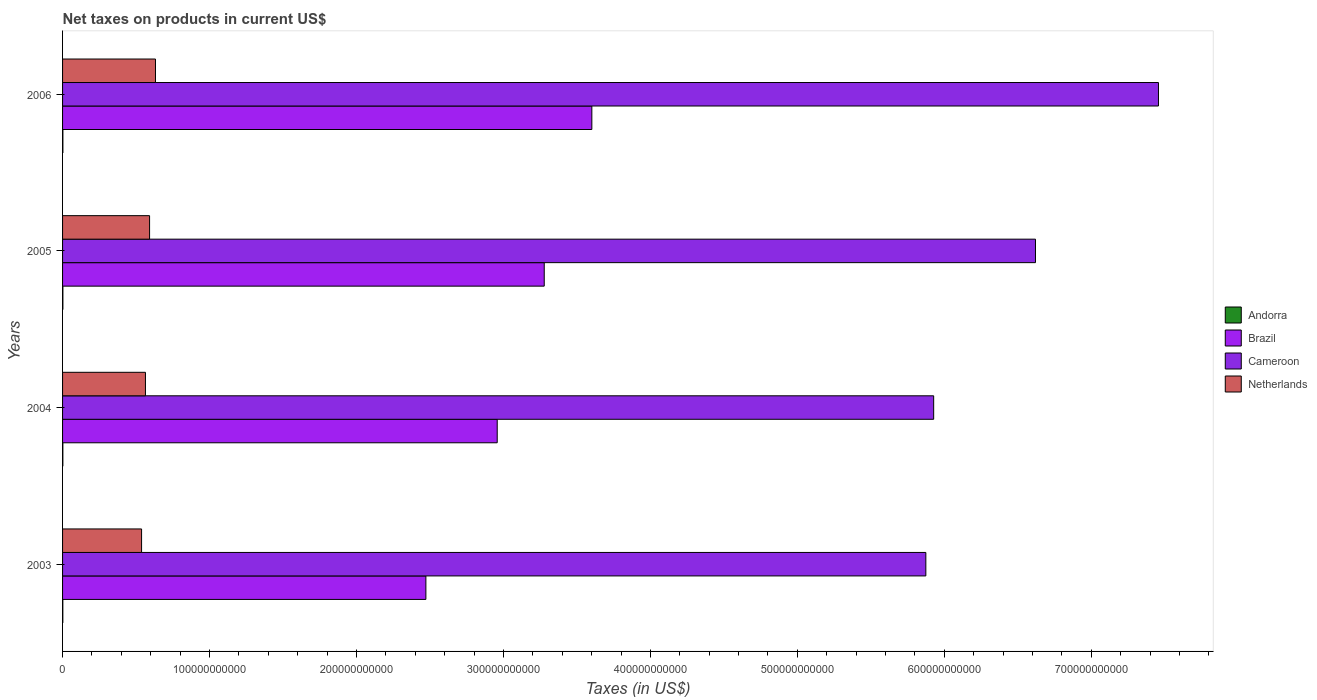Are the number of bars per tick equal to the number of legend labels?
Offer a terse response. Yes. How many bars are there on the 4th tick from the top?
Provide a succinct answer. 4. How many bars are there on the 1st tick from the bottom?
Ensure brevity in your answer.  4. What is the label of the 4th group of bars from the top?
Your response must be concise. 2003. What is the net taxes on products in Cameroon in 2005?
Your response must be concise. 6.62e+11. Across all years, what is the maximum net taxes on products in Brazil?
Make the answer very short. 3.60e+11. Across all years, what is the minimum net taxes on products in Andorra?
Your answer should be very brief. 1.74e+08. In which year was the net taxes on products in Cameroon maximum?
Offer a terse response. 2006. What is the total net taxes on products in Netherlands in the graph?
Your answer should be compact. 2.33e+11. What is the difference between the net taxes on products in Netherlands in 2004 and that in 2006?
Provide a short and direct response. -6.83e+09. What is the difference between the net taxes on products in Cameroon in 2006 and the net taxes on products in Brazil in 2003?
Offer a very short reply. 4.98e+11. What is the average net taxes on products in Netherlands per year?
Your response must be concise. 5.82e+1. In the year 2003, what is the difference between the net taxes on products in Brazil and net taxes on products in Netherlands?
Your answer should be very brief. 1.93e+11. What is the ratio of the net taxes on products in Brazil in 2004 to that in 2006?
Give a very brief answer. 0.82. Is the net taxes on products in Brazil in 2004 less than that in 2006?
Keep it short and to the point. Yes. What is the difference between the highest and the second highest net taxes on products in Brazil?
Offer a very short reply. 3.24e+1. What is the difference between the highest and the lowest net taxes on products in Cameroon?
Provide a short and direct response. 1.58e+11. Is it the case that in every year, the sum of the net taxes on products in Andorra and net taxes on products in Netherlands is greater than the sum of net taxes on products in Cameroon and net taxes on products in Brazil?
Ensure brevity in your answer.  No. What does the 1st bar from the top in 2003 represents?
Give a very brief answer. Netherlands. What does the 3rd bar from the bottom in 2005 represents?
Offer a terse response. Cameroon. How many bars are there?
Offer a terse response. 16. How many years are there in the graph?
Offer a terse response. 4. What is the difference between two consecutive major ticks on the X-axis?
Your response must be concise. 1.00e+11. Are the values on the major ticks of X-axis written in scientific E-notation?
Your answer should be very brief. No. Where does the legend appear in the graph?
Offer a terse response. Center right. How many legend labels are there?
Provide a succinct answer. 4. What is the title of the graph?
Offer a very short reply. Net taxes on products in current US$. Does "Malawi" appear as one of the legend labels in the graph?
Offer a very short reply. No. What is the label or title of the X-axis?
Give a very brief answer. Taxes (in US$). What is the Taxes (in US$) of Andorra in 2003?
Provide a succinct answer. 1.74e+08. What is the Taxes (in US$) of Brazil in 2003?
Provide a succinct answer. 2.47e+11. What is the Taxes (in US$) of Cameroon in 2003?
Ensure brevity in your answer.  5.87e+11. What is the Taxes (in US$) of Netherlands in 2003?
Provide a short and direct response. 5.38e+1. What is the Taxes (in US$) in Andorra in 2004?
Your answer should be very brief. 2.00e+08. What is the Taxes (in US$) of Brazil in 2004?
Give a very brief answer. 2.96e+11. What is the Taxes (in US$) of Cameroon in 2004?
Make the answer very short. 5.93e+11. What is the Taxes (in US$) in Netherlands in 2004?
Your response must be concise. 5.64e+1. What is the Taxes (in US$) of Andorra in 2005?
Make the answer very short. 2.24e+08. What is the Taxes (in US$) of Brazil in 2005?
Your answer should be compact. 3.28e+11. What is the Taxes (in US$) of Cameroon in 2005?
Offer a terse response. 6.62e+11. What is the Taxes (in US$) in Netherlands in 2005?
Your answer should be compact. 5.92e+1. What is the Taxes (in US$) in Andorra in 2006?
Offer a terse response. 2.23e+08. What is the Taxes (in US$) of Brazil in 2006?
Keep it short and to the point. 3.60e+11. What is the Taxes (in US$) of Cameroon in 2006?
Keep it short and to the point. 7.46e+11. What is the Taxes (in US$) in Netherlands in 2006?
Make the answer very short. 6.32e+1. Across all years, what is the maximum Taxes (in US$) of Andorra?
Give a very brief answer. 2.24e+08. Across all years, what is the maximum Taxes (in US$) of Brazil?
Offer a terse response. 3.60e+11. Across all years, what is the maximum Taxes (in US$) of Cameroon?
Your answer should be very brief. 7.46e+11. Across all years, what is the maximum Taxes (in US$) of Netherlands?
Ensure brevity in your answer.  6.32e+1. Across all years, what is the minimum Taxes (in US$) in Andorra?
Ensure brevity in your answer.  1.74e+08. Across all years, what is the minimum Taxes (in US$) in Brazil?
Offer a very short reply. 2.47e+11. Across all years, what is the minimum Taxes (in US$) of Cameroon?
Your answer should be compact. 5.87e+11. Across all years, what is the minimum Taxes (in US$) in Netherlands?
Your response must be concise. 5.38e+1. What is the total Taxes (in US$) of Andorra in the graph?
Your response must be concise. 8.20e+08. What is the total Taxes (in US$) in Brazil in the graph?
Provide a succinct answer. 1.23e+12. What is the total Taxes (in US$) of Cameroon in the graph?
Ensure brevity in your answer.  2.59e+12. What is the total Taxes (in US$) of Netherlands in the graph?
Provide a succinct answer. 2.33e+11. What is the difference between the Taxes (in US$) of Andorra in 2003 and that in 2004?
Your response must be concise. -2.60e+07. What is the difference between the Taxes (in US$) in Brazil in 2003 and that in 2004?
Offer a very short reply. -4.85e+1. What is the difference between the Taxes (in US$) in Cameroon in 2003 and that in 2004?
Your answer should be very brief. -5.34e+09. What is the difference between the Taxes (in US$) of Netherlands in 2003 and that in 2004?
Offer a terse response. -2.63e+09. What is the difference between the Taxes (in US$) of Andorra in 2003 and that in 2005?
Your response must be concise. -5.02e+07. What is the difference between the Taxes (in US$) of Brazil in 2003 and that in 2005?
Provide a short and direct response. -8.05e+1. What is the difference between the Taxes (in US$) in Cameroon in 2003 and that in 2005?
Offer a very short reply. -7.46e+1. What is the difference between the Taxes (in US$) of Netherlands in 2003 and that in 2005?
Provide a short and direct response. -5.44e+09. What is the difference between the Taxes (in US$) in Andorra in 2003 and that in 2006?
Give a very brief answer. -4.88e+07. What is the difference between the Taxes (in US$) in Brazil in 2003 and that in 2006?
Your response must be concise. -1.13e+11. What is the difference between the Taxes (in US$) of Cameroon in 2003 and that in 2006?
Provide a short and direct response. -1.58e+11. What is the difference between the Taxes (in US$) in Netherlands in 2003 and that in 2006?
Your answer should be compact. -9.46e+09. What is the difference between the Taxes (in US$) in Andorra in 2004 and that in 2005?
Make the answer very short. -2.42e+07. What is the difference between the Taxes (in US$) in Brazil in 2004 and that in 2005?
Provide a succinct answer. -3.20e+1. What is the difference between the Taxes (in US$) in Cameroon in 2004 and that in 2005?
Give a very brief answer. -6.93e+1. What is the difference between the Taxes (in US$) in Netherlands in 2004 and that in 2005?
Make the answer very short. -2.81e+09. What is the difference between the Taxes (in US$) in Andorra in 2004 and that in 2006?
Keep it short and to the point. -2.28e+07. What is the difference between the Taxes (in US$) of Brazil in 2004 and that in 2006?
Offer a very short reply. -6.44e+1. What is the difference between the Taxes (in US$) in Cameroon in 2004 and that in 2006?
Your response must be concise. -1.53e+11. What is the difference between the Taxes (in US$) of Netherlands in 2004 and that in 2006?
Provide a short and direct response. -6.83e+09. What is the difference between the Taxes (in US$) of Andorra in 2005 and that in 2006?
Your answer should be very brief. 1.46e+06. What is the difference between the Taxes (in US$) in Brazil in 2005 and that in 2006?
Give a very brief answer. -3.24e+1. What is the difference between the Taxes (in US$) in Cameroon in 2005 and that in 2006?
Give a very brief answer. -8.37e+1. What is the difference between the Taxes (in US$) of Netherlands in 2005 and that in 2006?
Your response must be concise. -4.02e+09. What is the difference between the Taxes (in US$) in Andorra in 2003 and the Taxes (in US$) in Brazil in 2004?
Give a very brief answer. -2.96e+11. What is the difference between the Taxes (in US$) in Andorra in 2003 and the Taxes (in US$) in Cameroon in 2004?
Your answer should be compact. -5.93e+11. What is the difference between the Taxes (in US$) of Andorra in 2003 and the Taxes (in US$) of Netherlands in 2004?
Ensure brevity in your answer.  -5.62e+1. What is the difference between the Taxes (in US$) of Brazil in 2003 and the Taxes (in US$) of Cameroon in 2004?
Keep it short and to the point. -3.46e+11. What is the difference between the Taxes (in US$) in Brazil in 2003 and the Taxes (in US$) in Netherlands in 2004?
Ensure brevity in your answer.  1.91e+11. What is the difference between the Taxes (in US$) in Cameroon in 2003 and the Taxes (in US$) in Netherlands in 2004?
Give a very brief answer. 5.31e+11. What is the difference between the Taxes (in US$) in Andorra in 2003 and the Taxes (in US$) in Brazil in 2005?
Your answer should be very brief. -3.28e+11. What is the difference between the Taxes (in US$) in Andorra in 2003 and the Taxes (in US$) in Cameroon in 2005?
Your answer should be very brief. -6.62e+11. What is the difference between the Taxes (in US$) in Andorra in 2003 and the Taxes (in US$) in Netherlands in 2005?
Your response must be concise. -5.90e+1. What is the difference between the Taxes (in US$) of Brazil in 2003 and the Taxes (in US$) of Cameroon in 2005?
Keep it short and to the point. -4.15e+11. What is the difference between the Taxes (in US$) of Brazil in 2003 and the Taxes (in US$) of Netherlands in 2005?
Ensure brevity in your answer.  1.88e+11. What is the difference between the Taxes (in US$) in Cameroon in 2003 and the Taxes (in US$) in Netherlands in 2005?
Your answer should be very brief. 5.28e+11. What is the difference between the Taxes (in US$) in Andorra in 2003 and the Taxes (in US$) in Brazil in 2006?
Your response must be concise. -3.60e+11. What is the difference between the Taxes (in US$) in Andorra in 2003 and the Taxes (in US$) in Cameroon in 2006?
Give a very brief answer. -7.46e+11. What is the difference between the Taxes (in US$) in Andorra in 2003 and the Taxes (in US$) in Netherlands in 2006?
Provide a succinct answer. -6.31e+1. What is the difference between the Taxes (in US$) of Brazil in 2003 and the Taxes (in US$) of Cameroon in 2006?
Your response must be concise. -4.98e+11. What is the difference between the Taxes (in US$) of Brazil in 2003 and the Taxes (in US$) of Netherlands in 2006?
Give a very brief answer. 1.84e+11. What is the difference between the Taxes (in US$) in Cameroon in 2003 and the Taxes (in US$) in Netherlands in 2006?
Your answer should be very brief. 5.24e+11. What is the difference between the Taxes (in US$) of Andorra in 2004 and the Taxes (in US$) of Brazil in 2005?
Your answer should be very brief. -3.28e+11. What is the difference between the Taxes (in US$) of Andorra in 2004 and the Taxes (in US$) of Cameroon in 2005?
Your response must be concise. -6.62e+11. What is the difference between the Taxes (in US$) of Andorra in 2004 and the Taxes (in US$) of Netherlands in 2005?
Your answer should be compact. -5.90e+1. What is the difference between the Taxes (in US$) of Brazil in 2004 and the Taxes (in US$) of Cameroon in 2005?
Offer a very short reply. -3.66e+11. What is the difference between the Taxes (in US$) of Brazil in 2004 and the Taxes (in US$) of Netherlands in 2005?
Offer a terse response. 2.37e+11. What is the difference between the Taxes (in US$) of Cameroon in 2004 and the Taxes (in US$) of Netherlands in 2005?
Your response must be concise. 5.34e+11. What is the difference between the Taxes (in US$) in Andorra in 2004 and the Taxes (in US$) in Brazil in 2006?
Your answer should be compact. -3.60e+11. What is the difference between the Taxes (in US$) in Andorra in 2004 and the Taxes (in US$) in Cameroon in 2006?
Keep it short and to the point. -7.46e+11. What is the difference between the Taxes (in US$) in Andorra in 2004 and the Taxes (in US$) in Netherlands in 2006?
Provide a short and direct response. -6.30e+1. What is the difference between the Taxes (in US$) in Brazil in 2004 and the Taxes (in US$) in Cameroon in 2006?
Your answer should be very brief. -4.50e+11. What is the difference between the Taxes (in US$) of Brazil in 2004 and the Taxes (in US$) of Netherlands in 2006?
Ensure brevity in your answer.  2.33e+11. What is the difference between the Taxes (in US$) of Cameroon in 2004 and the Taxes (in US$) of Netherlands in 2006?
Your response must be concise. 5.30e+11. What is the difference between the Taxes (in US$) of Andorra in 2005 and the Taxes (in US$) of Brazil in 2006?
Ensure brevity in your answer.  -3.60e+11. What is the difference between the Taxes (in US$) of Andorra in 2005 and the Taxes (in US$) of Cameroon in 2006?
Offer a very short reply. -7.46e+11. What is the difference between the Taxes (in US$) of Andorra in 2005 and the Taxes (in US$) of Netherlands in 2006?
Your response must be concise. -6.30e+1. What is the difference between the Taxes (in US$) in Brazil in 2005 and the Taxes (in US$) in Cameroon in 2006?
Your response must be concise. -4.18e+11. What is the difference between the Taxes (in US$) in Brazil in 2005 and the Taxes (in US$) in Netherlands in 2006?
Your answer should be compact. 2.65e+11. What is the difference between the Taxes (in US$) in Cameroon in 2005 and the Taxes (in US$) in Netherlands in 2006?
Make the answer very short. 5.99e+11. What is the average Taxes (in US$) in Andorra per year?
Give a very brief answer. 2.05e+08. What is the average Taxes (in US$) in Brazil per year?
Make the answer very short. 3.08e+11. What is the average Taxes (in US$) in Cameroon per year?
Your response must be concise. 6.47e+11. What is the average Taxes (in US$) of Netherlands per year?
Provide a succinct answer. 5.82e+1. In the year 2003, what is the difference between the Taxes (in US$) of Andorra and Taxes (in US$) of Brazil?
Ensure brevity in your answer.  -2.47e+11. In the year 2003, what is the difference between the Taxes (in US$) in Andorra and Taxes (in US$) in Cameroon?
Provide a short and direct response. -5.87e+11. In the year 2003, what is the difference between the Taxes (in US$) in Andorra and Taxes (in US$) in Netherlands?
Ensure brevity in your answer.  -5.36e+1. In the year 2003, what is the difference between the Taxes (in US$) in Brazil and Taxes (in US$) in Cameroon?
Offer a very short reply. -3.40e+11. In the year 2003, what is the difference between the Taxes (in US$) of Brazil and Taxes (in US$) of Netherlands?
Provide a short and direct response. 1.93e+11. In the year 2003, what is the difference between the Taxes (in US$) of Cameroon and Taxes (in US$) of Netherlands?
Provide a succinct answer. 5.34e+11. In the year 2004, what is the difference between the Taxes (in US$) of Andorra and Taxes (in US$) of Brazil?
Your answer should be compact. -2.96e+11. In the year 2004, what is the difference between the Taxes (in US$) of Andorra and Taxes (in US$) of Cameroon?
Keep it short and to the point. -5.93e+11. In the year 2004, what is the difference between the Taxes (in US$) in Andorra and Taxes (in US$) in Netherlands?
Keep it short and to the point. -5.62e+1. In the year 2004, what is the difference between the Taxes (in US$) of Brazil and Taxes (in US$) of Cameroon?
Keep it short and to the point. -2.97e+11. In the year 2004, what is the difference between the Taxes (in US$) of Brazil and Taxes (in US$) of Netherlands?
Keep it short and to the point. 2.39e+11. In the year 2004, what is the difference between the Taxes (in US$) in Cameroon and Taxes (in US$) in Netherlands?
Give a very brief answer. 5.36e+11. In the year 2005, what is the difference between the Taxes (in US$) in Andorra and Taxes (in US$) in Brazil?
Provide a succinct answer. -3.28e+11. In the year 2005, what is the difference between the Taxes (in US$) in Andorra and Taxes (in US$) in Cameroon?
Your answer should be very brief. -6.62e+11. In the year 2005, what is the difference between the Taxes (in US$) of Andorra and Taxes (in US$) of Netherlands?
Your response must be concise. -5.90e+1. In the year 2005, what is the difference between the Taxes (in US$) of Brazil and Taxes (in US$) of Cameroon?
Your answer should be compact. -3.34e+11. In the year 2005, what is the difference between the Taxes (in US$) in Brazil and Taxes (in US$) in Netherlands?
Keep it short and to the point. 2.69e+11. In the year 2005, what is the difference between the Taxes (in US$) of Cameroon and Taxes (in US$) of Netherlands?
Your answer should be very brief. 6.03e+11. In the year 2006, what is the difference between the Taxes (in US$) in Andorra and Taxes (in US$) in Brazil?
Your answer should be compact. -3.60e+11. In the year 2006, what is the difference between the Taxes (in US$) in Andorra and Taxes (in US$) in Cameroon?
Provide a short and direct response. -7.46e+11. In the year 2006, what is the difference between the Taxes (in US$) of Andorra and Taxes (in US$) of Netherlands?
Your response must be concise. -6.30e+1. In the year 2006, what is the difference between the Taxes (in US$) in Brazil and Taxes (in US$) in Cameroon?
Your answer should be compact. -3.86e+11. In the year 2006, what is the difference between the Taxes (in US$) of Brazil and Taxes (in US$) of Netherlands?
Keep it short and to the point. 2.97e+11. In the year 2006, what is the difference between the Taxes (in US$) of Cameroon and Taxes (in US$) of Netherlands?
Offer a very short reply. 6.83e+11. What is the ratio of the Taxes (in US$) in Andorra in 2003 to that in 2004?
Keep it short and to the point. 0.87. What is the ratio of the Taxes (in US$) in Brazil in 2003 to that in 2004?
Offer a very short reply. 0.84. What is the ratio of the Taxes (in US$) of Netherlands in 2003 to that in 2004?
Provide a short and direct response. 0.95. What is the ratio of the Taxes (in US$) of Andorra in 2003 to that in 2005?
Give a very brief answer. 0.78. What is the ratio of the Taxes (in US$) of Brazil in 2003 to that in 2005?
Provide a short and direct response. 0.75. What is the ratio of the Taxes (in US$) in Cameroon in 2003 to that in 2005?
Give a very brief answer. 0.89. What is the ratio of the Taxes (in US$) of Netherlands in 2003 to that in 2005?
Your response must be concise. 0.91. What is the ratio of the Taxes (in US$) in Andorra in 2003 to that in 2006?
Provide a succinct answer. 0.78. What is the ratio of the Taxes (in US$) of Brazil in 2003 to that in 2006?
Offer a very short reply. 0.69. What is the ratio of the Taxes (in US$) in Cameroon in 2003 to that in 2006?
Your response must be concise. 0.79. What is the ratio of the Taxes (in US$) of Netherlands in 2003 to that in 2006?
Your answer should be very brief. 0.85. What is the ratio of the Taxes (in US$) in Andorra in 2004 to that in 2005?
Offer a terse response. 0.89. What is the ratio of the Taxes (in US$) in Brazil in 2004 to that in 2005?
Provide a short and direct response. 0.9. What is the ratio of the Taxes (in US$) of Cameroon in 2004 to that in 2005?
Your answer should be compact. 0.9. What is the ratio of the Taxes (in US$) in Netherlands in 2004 to that in 2005?
Your answer should be compact. 0.95. What is the ratio of the Taxes (in US$) in Andorra in 2004 to that in 2006?
Ensure brevity in your answer.  0.9. What is the ratio of the Taxes (in US$) of Brazil in 2004 to that in 2006?
Ensure brevity in your answer.  0.82. What is the ratio of the Taxes (in US$) in Cameroon in 2004 to that in 2006?
Your answer should be very brief. 0.79. What is the ratio of the Taxes (in US$) in Netherlands in 2004 to that in 2006?
Your response must be concise. 0.89. What is the ratio of the Taxes (in US$) of Andorra in 2005 to that in 2006?
Your answer should be very brief. 1.01. What is the ratio of the Taxes (in US$) of Brazil in 2005 to that in 2006?
Give a very brief answer. 0.91. What is the ratio of the Taxes (in US$) of Cameroon in 2005 to that in 2006?
Make the answer very short. 0.89. What is the ratio of the Taxes (in US$) in Netherlands in 2005 to that in 2006?
Keep it short and to the point. 0.94. What is the difference between the highest and the second highest Taxes (in US$) of Andorra?
Make the answer very short. 1.46e+06. What is the difference between the highest and the second highest Taxes (in US$) in Brazil?
Provide a succinct answer. 3.24e+1. What is the difference between the highest and the second highest Taxes (in US$) of Cameroon?
Make the answer very short. 8.37e+1. What is the difference between the highest and the second highest Taxes (in US$) in Netherlands?
Offer a terse response. 4.02e+09. What is the difference between the highest and the lowest Taxes (in US$) in Andorra?
Provide a short and direct response. 5.02e+07. What is the difference between the highest and the lowest Taxes (in US$) of Brazil?
Make the answer very short. 1.13e+11. What is the difference between the highest and the lowest Taxes (in US$) of Cameroon?
Ensure brevity in your answer.  1.58e+11. What is the difference between the highest and the lowest Taxes (in US$) of Netherlands?
Your response must be concise. 9.46e+09. 